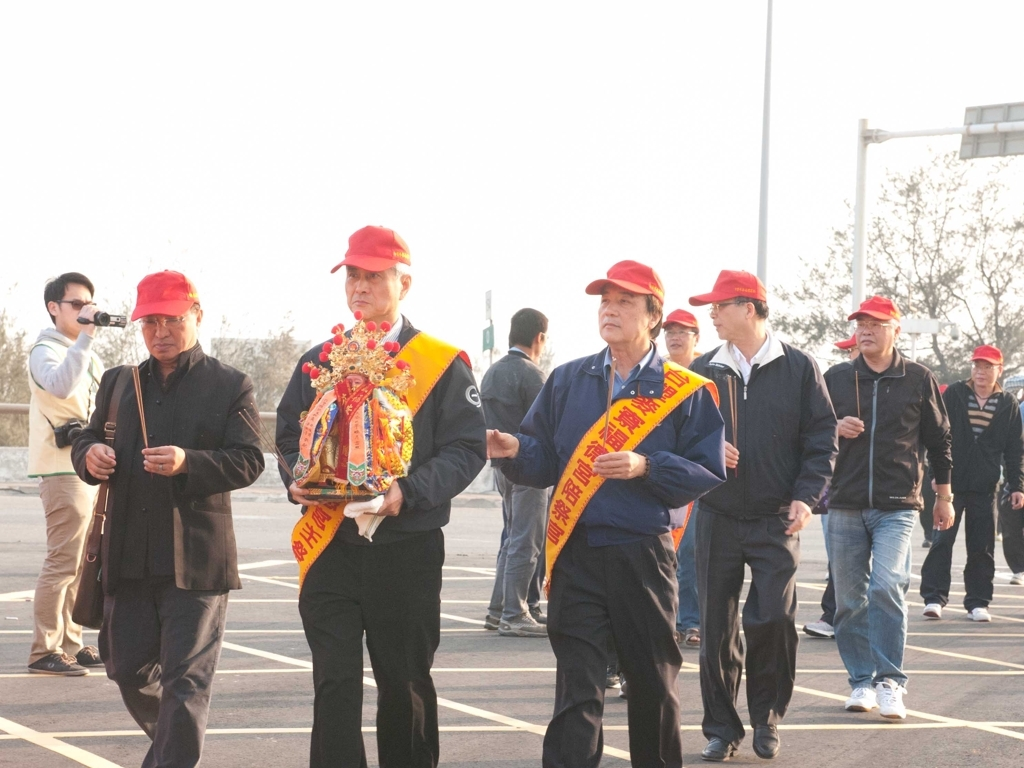Describe what kind of event might be taking place here. The individuals in the photograph are likely participating in a ceremonial procession. The red caps, sashes, and the ornate palanquin-like object suggest a traditional event, possibly connected to local beliefs or a festival. The banners they wear might indicate their roles or the name of the group they represent in this celebration. What does their attire indicate about the nature of the event or their roles? Their coordinated attire, featuring red caps and sashes with golden lettering, implies a sense of formality and unity. Such outfits are often associated with ceremonial roles; for example, they might be stewards or honored members of the community leading or playing important roles in the procession. 